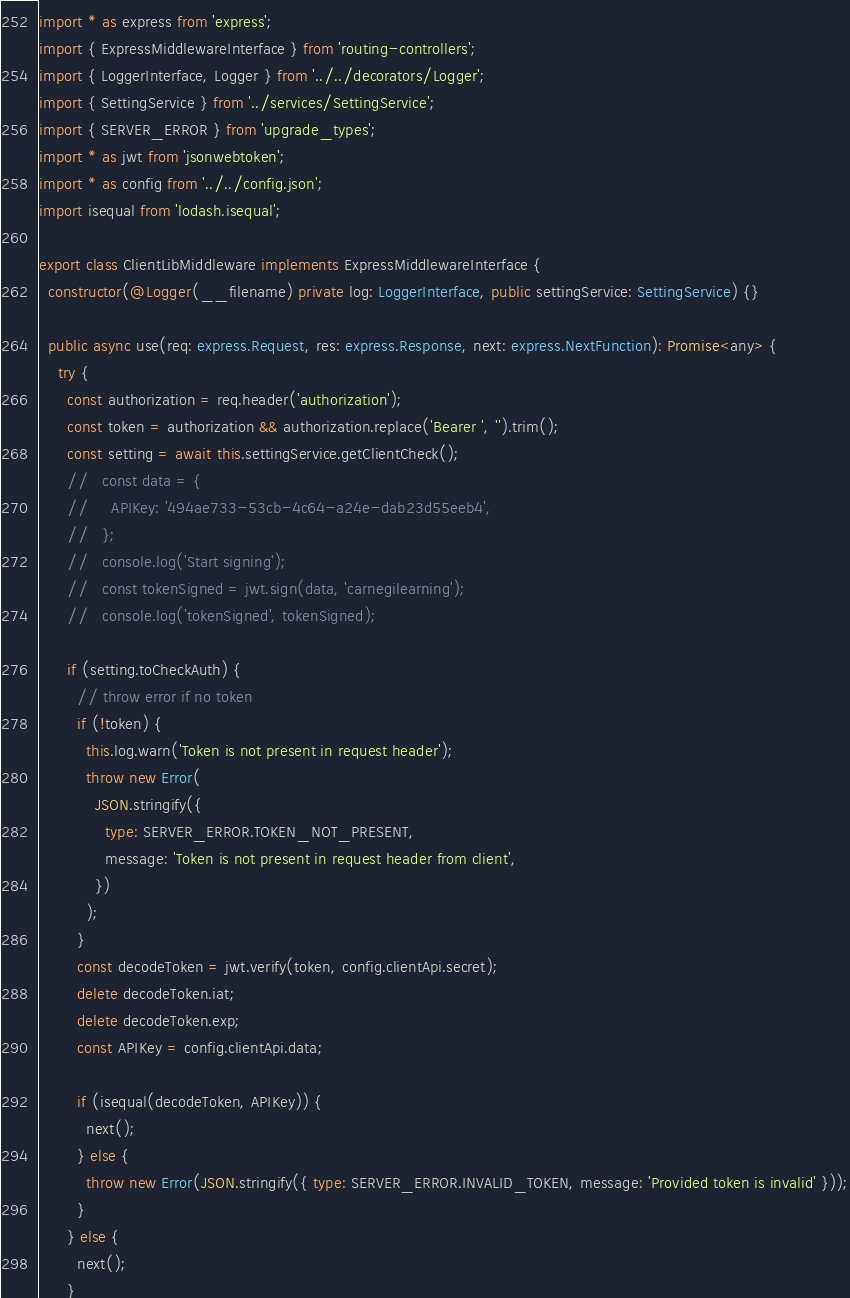<code> <loc_0><loc_0><loc_500><loc_500><_TypeScript_>import * as express from 'express';
import { ExpressMiddlewareInterface } from 'routing-controllers';
import { LoggerInterface, Logger } from '../../decorators/Logger';
import { SettingService } from '../services/SettingService';
import { SERVER_ERROR } from 'upgrade_types';
import * as jwt from 'jsonwebtoken';
import * as config from '../../config.json';
import isequal from 'lodash.isequal';

export class ClientLibMiddleware implements ExpressMiddlewareInterface {
  constructor(@Logger(__filename) private log: LoggerInterface, public settingService: SettingService) {}

  public async use(req: express.Request, res: express.Response, next: express.NextFunction): Promise<any> {
    try {
      const authorization = req.header('authorization');
      const token = authorization && authorization.replace('Bearer ', '').trim();
      const setting = await this.settingService.getClientCheck();
      //   const data = {
      //     APIKey: '494ae733-53cb-4c64-a24e-dab23d55eeb4',
      //   };
      //   console.log('Start signing');
      //   const tokenSigned = jwt.sign(data, 'carnegilearning');
      //   console.log('tokenSigned', tokenSigned);

      if (setting.toCheckAuth) {
        // throw error if no token
        if (!token) {
          this.log.warn('Token is not present in request header');
          throw new Error(
            JSON.stringify({
              type: SERVER_ERROR.TOKEN_NOT_PRESENT,
              message: 'Token is not present in request header from client',
            })
          );
        }
        const decodeToken = jwt.verify(token, config.clientApi.secret);
        delete decodeToken.iat;
        delete decodeToken.exp;
        const APIKey = config.clientApi.data;

        if (isequal(decodeToken, APIKey)) {
          next();
        } else {
          throw new Error(JSON.stringify({ type: SERVER_ERROR.INVALID_TOKEN, message: 'Provided token is invalid' }));
        }
      } else {
        next();
      }</code> 